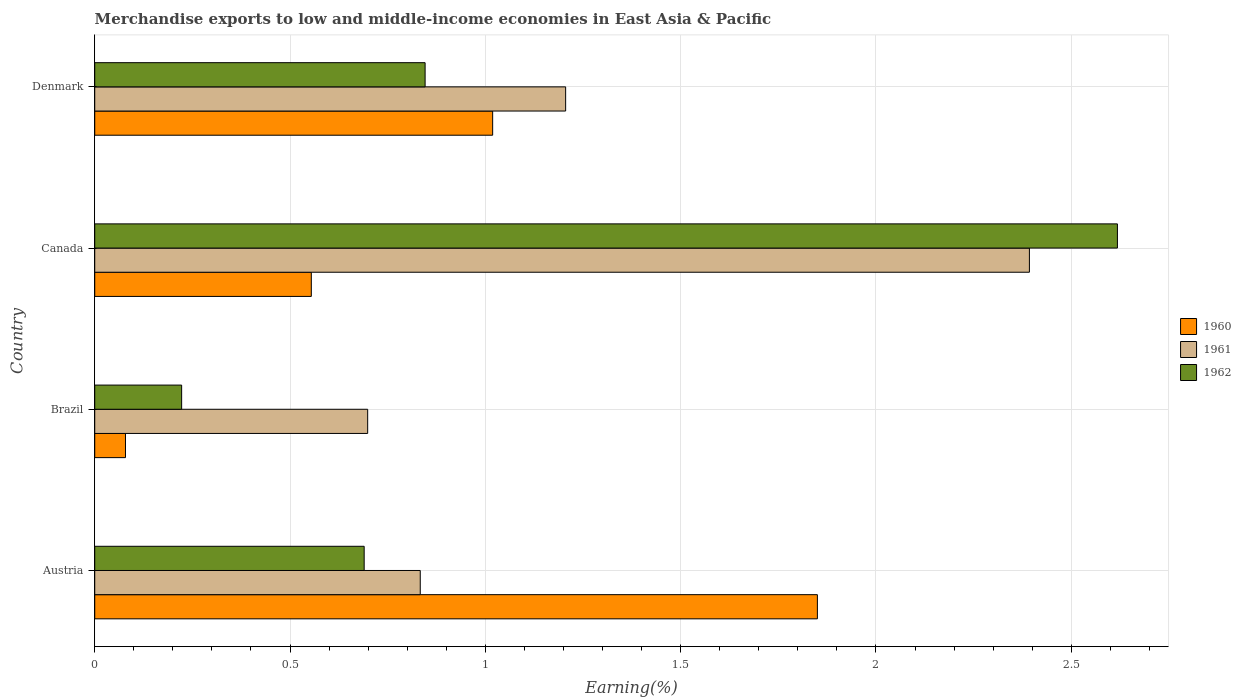How many different coloured bars are there?
Your response must be concise. 3. What is the percentage of amount earned from merchandise exports in 1960 in Canada?
Your response must be concise. 0.55. Across all countries, what is the maximum percentage of amount earned from merchandise exports in 1961?
Your answer should be compact. 2.39. Across all countries, what is the minimum percentage of amount earned from merchandise exports in 1961?
Offer a very short reply. 0.7. What is the total percentage of amount earned from merchandise exports in 1960 in the graph?
Ensure brevity in your answer.  3.5. What is the difference between the percentage of amount earned from merchandise exports in 1962 in Austria and that in Denmark?
Offer a terse response. -0.16. What is the difference between the percentage of amount earned from merchandise exports in 1962 in Denmark and the percentage of amount earned from merchandise exports in 1961 in Austria?
Make the answer very short. 0.01. What is the average percentage of amount earned from merchandise exports in 1960 per country?
Ensure brevity in your answer.  0.88. What is the difference between the percentage of amount earned from merchandise exports in 1961 and percentage of amount earned from merchandise exports in 1962 in Austria?
Your answer should be very brief. 0.14. In how many countries, is the percentage of amount earned from merchandise exports in 1961 greater than 1.8 %?
Keep it short and to the point. 1. What is the ratio of the percentage of amount earned from merchandise exports in 1961 in Brazil to that in Canada?
Keep it short and to the point. 0.29. What is the difference between the highest and the second highest percentage of amount earned from merchandise exports in 1960?
Make the answer very short. 0.83. What is the difference between the highest and the lowest percentage of amount earned from merchandise exports in 1961?
Your response must be concise. 1.69. In how many countries, is the percentage of amount earned from merchandise exports in 1962 greater than the average percentage of amount earned from merchandise exports in 1962 taken over all countries?
Your answer should be compact. 1. Is the sum of the percentage of amount earned from merchandise exports in 1961 in Brazil and Denmark greater than the maximum percentage of amount earned from merchandise exports in 1960 across all countries?
Provide a succinct answer. Yes. What does the 1st bar from the bottom in Brazil represents?
Your response must be concise. 1960. Is it the case that in every country, the sum of the percentage of amount earned from merchandise exports in 1960 and percentage of amount earned from merchandise exports in 1962 is greater than the percentage of amount earned from merchandise exports in 1961?
Your answer should be very brief. No. How many bars are there?
Your answer should be very brief. 12. Are all the bars in the graph horizontal?
Offer a very short reply. Yes. Does the graph contain any zero values?
Give a very brief answer. No. How many legend labels are there?
Offer a terse response. 3. How are the legend labels stacked?
Your answer should be compact. Vertical. What is the title of the graph?
Provide a short and direct response. Merchandise exports to low and middle-income economies in East Asia & Pacific. Does "1989" appear as one of the legend labels in the graph?
Give a very brief answer. No. What is the label or title of the X-axis?
Provide a short and direct response. Earning(%). What is the Earning(%) of 1960 in Austria?
Ensure brevity in your answer.  1.85. What is the Earning(%) in 1961 in Austria?
Your answer should be very brief. 0.83. What is the Earning(%) of 1962 in Austria?
Keep it short and to the point. 0.69. What is the Earning(%) in 1960 in Brazil?
Offer a very short reply. 0.08. What is the Earning(%) of 1961 in Brazil?
Offer a very short reply. 0.7. What is the Earning(%) of 1962 in Brazil?
Provide a short and direct response. 0.22. What is the Earning(%) of 1960 in Canada?
Provide a succinct answer. 0.55. What is the Earning(%) of 1961 in Canada?
Offer a very short reply. 2.39. What is the Earning(%) of 1962 in Canada?
Keep it short and to the point. 2.62. What is the Earning(%) of 1960 in Denmark?
Keep it short and to the point. 1.02. What is the Earning(%) of 1961 in Denmark?
Ensure brevity in your answer.  1.21. What is the Earning(%) of 1962 in Denmark?
Give a very brief answer. 0.85. Across all countries, what is the maximum Earning(%) of 1960?
Keep it short and to the point. 1.85. Across all countries, what is the maximum Earning(%) of 1961?
Your response must be concise. 2.39. Across all countries, what is the maximum Earning(%) in 1962?
Provide a short and direct response. 2.62. Across all countries, what is the minimum Earning(%) in 1960?
Your answer should be very brief. 0.08. Across all countries, what is the minimum Earning(%) of 1961?
Give a very brief answer. 0.7. Across all countries, what is the minimum Earning(%) of 1962?
Your answer should be compact. 0.22. What is the total Earning(%) in 1960 in the graph?
Your answer should be compact. 3.5. What is the total Earning(%) of 1961 in the graph?
Your response must be concise. 5.13. What is the total Earning(%) in 1962 in the graph?
Offer a terse response. 4.38. What is the difference between the Earning(%) in 1960 in Austria and that in Brazil?
Your response must be concise. 1.77. What is the difference between the Earning(%) in 1961 in Austria and that in Brazil?
Provide a succinct answer. 0.13. What is the difference between the Earning(%) of 1962 in Austria and that in Brazil?
Give a very brief answer. 0.47. What is the difference between the Earning(%) in 1960 in Austria and that in Canada?
Give a very brief answer. 1.3. What is the difference between the Earning(%) of 1961 in Austria and that in Canada?
Your answer should be compact. -1.56. What is the difference between the Earning(%) of 1962 in Austria and that in Canada?
Offer a very short reply. -1.93. What is the difference between the Earning(%) of 1960 in Austria and that in Denmark?
Make the answer very short. 0.83. What is the difference between the Earning(%) of 1961 in Austria and that in Denmark?
Provide a short and direct response. -0.37. What is the difference between the Earning(%) in 1962 in Austria and that in Denmark?
Your response must be concise. -0.16. What is the difference between the Earning(%) in 1960 in Brazil and that in Canada?
Your answer should be compact. -0.48. What is the difference between the Earning(%) in 1961 in Brazil and that in Canada?
Make the answer very short. -1.69. What is the difference between the Earning(%) of 1962 in Brazil and that in Canada?
Provide a short and direct response. -2.4. What is the difference between the Earning(%) in 1960 in Brazil and that in Denmark?
Keep it short and to the point. -0.94. What is the difference between the Earning(%) of 1961 in Brazil and that in Denmark?
Keep it short and to the point. -0.51. What is the difference between the Earning(%) in 1962 in Brazil and that in Denmark?
Ensure brevity in your answer.  -0.62. What is the difference between the Earning(%) of 1960 in Canada and that in Denmark?
Provide a succinct answer. -0.46. What is the difference between the Earning(%) in 1961 in Canada and that in Denmark?
Ensure brevity in your answer.  1.19. What is the difference between the Earning(%) in 1962 in Canada and that in Denmark?
Offer a terse response. 1.77. What is the difference between the Earning(%) of 1960 in Austria and the Earning(%) of 1961 in Brazil?
Provide a succinct answer. 1.15. What is the difference between the Earning(%) of 1960 in Austria and the Earning(%) of 1962 in Brazil?
Provide a short and direct response. 1.63. What is the difference between the Earning(%) of 1961 in Austria and the Earning(%) of 1962 in Brazil?
Offer a terse response. 0.61. What is the difference between the Earning(%) in 1960 in Austria and the Earning(%) in 1961 in Canada?
Make the answer very short. -0.54. What is the difference between the Earning(%) in 1960 in Austria and the Earning(%) in 1962 in Canada?
Your answer should be compact. -0.77. What is the difference between the Earning(%) in 1961 in Austria and the Earning(%) in 1962 in Canada?
Ensure brevity in your answer.  -1.78. What is the difference between the Earning(%) of 1960 in Austria and the Earning(%) of 1961 in Denmark?
Make the answer very short. 0.64. What is the difference between the Earning(%) of 1960 in Austria and the Earning(%) of 1962 in Denmark?
Provide a succinct answer. 1. What is the difference between the Earning(%) of 1961 in Austria and the Earning(%) of 1962 in Denmark?
Your answer should be compact. -0.01. What is the difference between the Earning(%) in 1960 in Brazil and the Earning(%) in 1961 in Canada?
Provide a short and direct response. -2.31. What is the difference between the Earning(%) in 1960 in Brazil and the Earning(%) in 1962 in Canada?
Offer a very short reply. -2.54. What is the difference between the Earning(%) in 1961 in Brazil and the Earning(%) in 1962 in Canada?
Offer a terse response. -1.92. What is the difference between the Earning(%) in 1960 in Brazil and the Earning(%) in 1961 in Denmark?
Ensure brevity in your answer.  -1.13. What is the difference between the Earning(%) of 1960 in Brazil and the Earning(%) of 1962 in Denmark?
Offer a terse response. -0.77. What is the difference between the Earning(%) of 1961 in Brazil and the Earning(%) of 1962 in Denmark?
Your answer should be compact. -0.15. What is the difference between the Earning(%) of 1960 in Canada and the Earning(%) of 1961 in Denmark?
Keep it short and to the point. -0.65. What is the difference between the Earning(%) of 1960 in Canada and the Earning(%) of 1962 in Denmark?
Offer a terse response. -0.29. What is the difference between the Earning(%) in 1961 in Canada and the Earning(%) in 1962 in Denmark?
Offer a very short reply. 1.55. What is the average Earning(%) in 1960 per country?
Provide a short and direct response. 0.88. What is the average Earning(%) of 1961 per country?
Keep it short and to the point. 1.28. What is the average Earning(%) in 1962 per country?
Give a very brief answer. 1.09. What is the difference between the Earning(%) of 1960 and Earning(%) of 1961 in Austria?
Offer a very short reply. 1.02. What is the difference between the Earning(%) of 1960 and Earning(%) of 1962 in Austria?
Offer a very short reply. 1.16. What is the difference between the Earning(%) in 1961 and Earning(%) in 1962 in Austria?
Your response must be concise. 0.14. What is the difference between the Earning(%) in 1960 and Earning(%) in 1961 in Brazil?
Offer a very short reply. -0.62. What is the difference between the Earning(%) of 1960 and Earning(%) of 1962 in Brazil?
Ensure brevity in your answer.  -0.14. What is the difference between the Earning(%) of 1961 and Earning(%) of 1962 in Brazil?
Make the answer very short. 0.48. What is the difference between the Earning(%) in 1960 and Earning(%) in 1961 in Canada?
Your answer should be compact. -1.84. What is the difference between the Earning(%) of 1960 and Earning(%) of 1962 in Canada?
Offer a very short reply. -2.06. What is the difference between the Earning(%) of 1961 and Earning(%) of 1962 in Canada?
Provide a succinct answer. -0.23. What is the difference between the Earning(%) in 1960 and Earning(%) in 1961 in Denmark?
Provide a short and direct response. -0.19. What is the difference between the Earning(%) in 1960 and Earning(%) in 1962 in Denmark?
Your answer should be very brief. 0.17. What is the difference between the Earning(%) in 1961 and Earning(%) in 1962 in Denmark?
Your response must be concise. 0.36. What is the ratio of the Earning(%) of 1960 in Austria to that in Brazil?
Make the answer very short. 23.49. What is the ratio of the Earning(%) of 1961 in Austria to that in Brazil?
Give a very brief answer. 1.19. What is the ratio of the Earning(%) in 1962 in Austria to that in Brazil?
Your answer should be very brief. 3.1. What is the ratio of the Earning(%) of 1960 in Austria to that in Canada?
Your answer should be compact. 3.34. What is the ratio of the Earning(%) in 1961 in Austria to that in Canada?
Your response must be concise. 0.35. What is the ratio of the Earning(%) of 1962 in Austria to that in Canada?
Your answer should be very brief. 0.26. What is the ratio of the Earning(%) in 1960 in Austria to that in Denmark?
Ensure brevity in your answer.  1.82. What is the ratio of the Earning(%) of 1961 in Austria to that in Denmark?
Provide a short and direct response. 0.69. What is the ratio of the Earning(%) in 1962 in Austria to that in Denmark?
Offer a very short reply. 0.82. What is the ratio of the Earning(%) in 1960 in Brazil to that in Canada?
Provide a short and direct response. 0.14. What is the ratio of the Earning(%) in 1961 in Brazil to that in Canada?
Your answer should be compact. 0.29. What is the ratio of the Earning(%) in 1962 in Brazil to that in Canada?
Your answer should be very brief. 0.09. What is the ratio of the Earning(%) of 1960 in Brazil to that in Denmark?
Offer a very short reply. 0.08. What is the ratio of the Earning(%) of 1961 in Brazil to that in Denmark?
Provide a short and direct response. 0.58. What is the ratio of the Earning(%) of 1962 in Brazil to that in Denmark?
Offer a very short reply. 0.26. What is the ratio of the Earning(%) in 1960 in Canada to that in Denmark?
Your response must be concise. 0.54. What is the ratio of the Earning(%) in 1961 in Canada to that in Denmark?
Offer a very short reply. 1.98. What is the ratio of the Earning(%) in 1962 in Canada to that in Denmark?
Offer a very short reply. 3.1. What is the difference between the highest and the second highest Earning(%) in 1960?
Your answer should be very brief. 0.83. What is the difference between the highest and the second highest Earning(%) in 1961?
Your answer should be very brief. 1.19. What is the difference between the highest and the second highest Earning(%) in 1962?
Your answer should be very brief. 1.77. What is the difference between the highest and the lowest Earning(%) in 1960?
Offer a terse response. 1.77. What is the difference between the highest and the lowest Earning(%) of 1961?
Your response must be concise. 1.69. What is the difference between the highest and the lowest Earning(%) in 1962?
Make the answer very short. 2.4. 